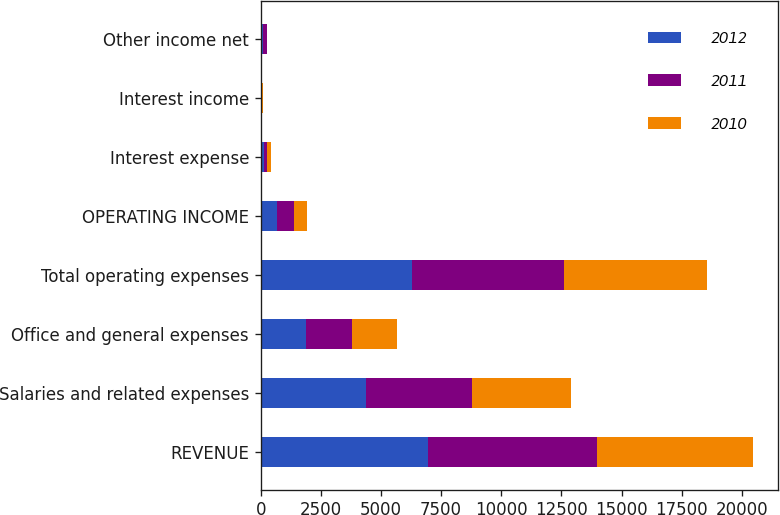Convert chart. <chart><loc_0><loc_0><loc_500><loc_500><stacked_bar_chart><ecel><fcel>REVENUE<fcel>Salaries and related expenses<fcel>Office and general expenses<fcel>Total operating expenses<fcel>OPERATING INCOME<fcel>Interest expense<fcel>Interest income<fcel>Other income net<nl><fcel>2012<fcel>6956.2<fcel>4391.9<fcel>1886<fcel>6277.9<fcel>678.3<fcel>133.5<fcel>29.5<fcel>100.5<nl><fcel>2011<fcel>7014.6<fcel>4402.1<fcel>1925.3<fcel>6327.4<fcel>687.2<fcel>136.8<fcel>37.8<fcel>150.2<nl><fcel>2010<fcel>6507.3<fcel>4117<fcel>1841.6<fcel>5958.6<fcel>548.7<fcel>139.7<fcel>28.7<fcel>12.9<nl></chart> 